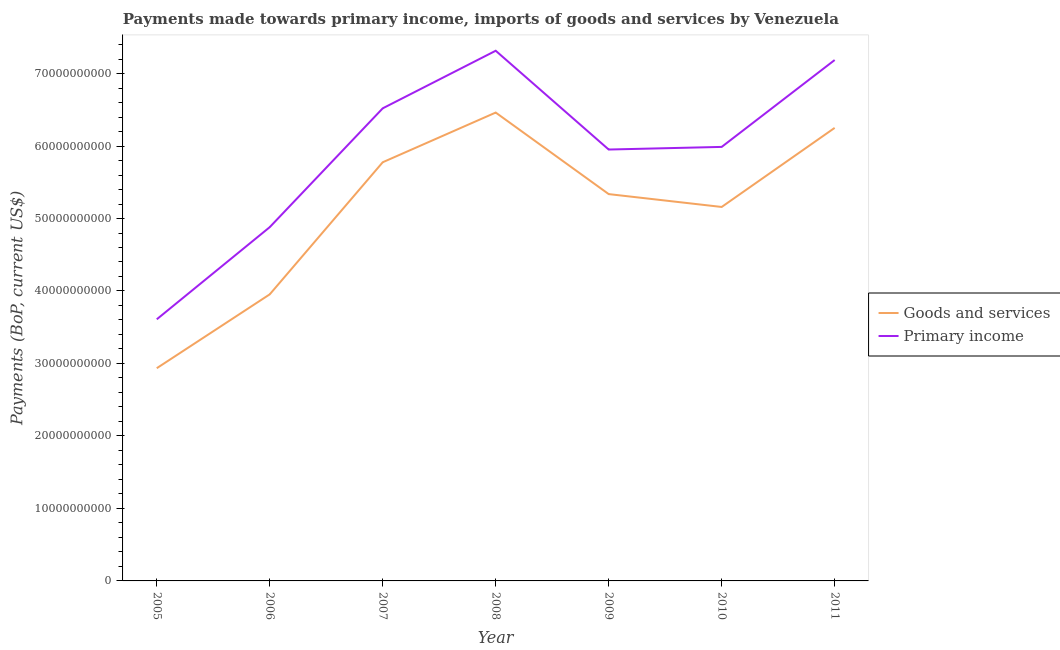How many different coloured lines are there?
Provide a short and direct response. 2. Does the line corresponding to payments made towards goods and services intersect with the line corresponding to payments made towards primary income?
Provide a short and direct response. No. What is the payments made towards primary income in 2008?
Provide a short and direct response. 7.31e+1. Across all years, what is the maximum payments made towards primary income?
Offer a terse response. 7.31e+1. Across all years, what is the minimum payments made towards goods and services?
Your answer should be compact. 2.93e+1. In which year was the payments made towards goods and services maximum?
Give a very brief answer. 2008. In which year was the payments made towards primary income minimum?
Provide a short and direct response. 2005. What is the total payments made towards primary income in the graph?
Provide a short and direct response. 4.15e+11. What is the difference between the payments made towards goods and services in 2008 and that in 2010?
Your answer should be very brief. 1.30e+1. What is the difference between the payments made towards primary income in 2009 and the payments made towards goods and services in 2008?
Offer a very short reply. -5.10e+09. What is the average payments made towards primary income per year?
Offer a very short reply. 5.92e+1. In the year 2008, what is the difference between the payments made towards primary income and payments made towards goods and services?
Provide a succinct answer. 8.53e+09. In how many years, is the payments made towards goods and services greater than 42000000000 US$?
Offer a terse response. 5. What is the ratio of the payments made towards primary income in 2005 to that in 2007?
Provide a succinct answer. 0.55. Is the payments made towards goods and services in 2006 less than that in 2010?
Offer a very short reply. Yes. What is the difference between the highest and the second highest payments made towards primary income?
Your answer should be very brief. 1.28e+09. What is the difference between the highest and the lowest payments made towards primary income?
Offer a terse response. 3.71e+1. Does the payments made towards goods and services monotonically increase over the years?
Offer a terse response. No. Is the payments made towards primary income strictly greater than the payments made towards goods and services over the years?
Keep it short and to the point. Yes. Is the payments made towards primary income strictly less than the payments made towards goods and services over the years?
Offer a terse response. No. How many lines are there?
Your answer should be compact. 2. Are the values on the major ticks of Y-axis written in scientific E-notation?
Your answer should be compact. No. Does the graph contain any zero values?
Your response must be concise. No. How many legend labels are there?
Provide a succinct answer. 2. What is the title of the graph?
Make the answer very short. Payments made towards primary income, imports of goods and services by Venezuela. What is the label or title of the X-axis?
Provide a succinct answer. Year. What is the label or title of the Y-axis?
Offer a very short reply. Payments (BoP, current US$). What is the Payments (BoP, current US$) in Goods and services in 2005?
Give a very brief answer. 2.93e+1. What is the Payments (BoP, current US$) of Primary income in 2005?
Provide a short and direct response. 3.61e+1. What is the Payments (BoP, current US$) in Goods and services in 2006?
Offer a very short reply. 3.95e+1. What is the Payments (BoP, current US$) of Primary income in 2006?
Keep it short and to the point. 4.88e+1. What is the Payments (BoP, current US$) in Goods and services in 2007?
Keep it short and to the point. 5.78e+1. What is the Payments (BoP, current US$) in Primary income in 2007?
Keep it short and to the point. 6.52e+1. What is the Payments (BoP, current US$) of Goods and services in 2008?
Your answer should be very brief. 6.46e+1. What is the Payments (BoP, current US$) in Primary income in 2008?
Make the answer very short. 7.31e+1. What is the Payments (BoP, current US$) of Goods and services in 2009?
Your answer should be very brief. 5.34e+1. What is the Payments (BoP, current US$) of Primary income in 2009?
Offer a terse response. 5.95e+1. What is the Payments (BoP, current US$) of Goods and services in 2010?
Provide a succinct answer. 5.16e+1. What is the Payments (BoP, current US$) of Primary income in 2010?
Your answer should be very brief. 5.99e+1. What is the Payments (BoP, current US$) in Goods and services in 2011?
Make the answer very short. 6.25e+1. What is the Payments (BoP, current US$) in Primary income in 2011?
Provide a short and direct response. 7.19e+1. Across all years, what is the maximum Payments (BoP, current US$) in Goods and services?
Your response must be concise. 6.46e+1. Across all years, what is the maximum Payments (BoP, current US$) of Primary income?
Your answer should be very brief. 7.31e+1. Across all years, what is the minimum Payments (BoP, current US$) in Goods and services?
Offer a very short reply. 2.93e+1. Across all years, what is the minimum Payments (BoP, current US$) of Primary income?
Keep it short and to the point. 3.61e+1. What is the total Payments (BoP, current US$) in Goods and services in the graph?
Provide a short and direct response. 3.59e+11. What is the total Payments (BoP, current US$) in Primary income in the graph?
Ensure brevity in your answer.  4.15e+11. What is the difference between the Payments (BoP, current US$) in Goods and services in 2005 and that in 2006?
Your response must be concise. -1.02e+1. What is the difference between the Payments (BoP, current US$) in Primary income in 2005 and that in 2006?
Give a very brief answer. -1.27e+1. What is the difference between the Payments (BoP, current US$) of Goods and services in 2005 and that in 2007?
Your answer should be compact. -2.84e+1. What is the difference between the Payments (BoP, current US$) in Primary income in 2005 and that in 2007?
Keep it short and to the point. -2.91e+1. What is the difference between the Payments (BoP, current US$) in Goods and services in 2005 and that in 2008?
Your answer should be compact. -3.53e+1. What is the difference between the Payments (BoP, current US$) of Primary income in 2005 and that in 2008?
Offer a very short reply. -3.71e+1. What is the difference between the Payments (BoP, current US$) in Goods and services in 2005 and that in 2009?
Your answer should be compact. -2.40e+1. What is the difference between the Payments (BoP, current US$) of Primary income in 2005 and that in 2009?
Give a very brief answer. -2.34e+1. What is the difference between the Payments (BoP, current US$) of Goods and services in 2005 and that in 2010?
Make the answer very short. -2.22e+1. What is the difference between the Payments (BoP, current US$) in Primary income in 2005 and that in 2010?
Provide a succinct answer. -2.38e+1. What is the difference between the Payments (BoP, current US$) of Goods and services in 2005 and that in 2011?
Ensure brevity in your answer.  -3.32e+1. What is the difference between the Payments (BoP, current US$) in Primary income in 2005 and that in 2011?
Provide a short and direct response. -3.58e+1. What is the difference between the Payments (BoP, current US$) in Goods and services in 2006 and that in 2007?
Provide a succinct answer. -1.82e+1. What is the difference between the Payments (BoP, current US$) of Primary income in 2006 and that in 2007?
Your answer should be very brief. -1.64e+1. What is the difference between the Payments (BoP, current US$) in Goods and services in 2006 and that in 2008?
Your answer should be compact. -2.51e+1. What is the difference between the Payments (BoP, current US$) of Primary income in 2006 and that in 2008?
Offer a terse response. -2.43e+1. What is the difference between the Payments (BoP, current US$) in Goods and services in 2006 and that in 2009?
Your answer should be compact. -1.38e+1. What is the difference between the Payments (BoP, current US$) in Primary income in 2006 and that in 2009?
Your response must be concise. -1.07e+1. What is the difference between the Payments (BoP, current US$) in Goods and services in 2006 and that in 2010?
Your answer should be compact. -1.21e+1. What is the difference between the Payments (BoP, current US$) of Primary income in 2006 and that in 2010?
Provide a short and direct response. -1.11e+1. What is the difference between the Payments (BoP, current US$) in Goods and services in 2006 and that in 2011?
Ensure brevity in your answer.  -2.30e+1. What is the difference between the Payments (BoP, current US$) in Primary income in 2006 and that in 2011?
Provide a short and direct response. -2.31e+1. What is the difference between the Payments (BoP, current US$) in Goods and services in 2007 and that in 2008?
Make the answer very short. -6.86e+09. What is the difference between the Payments (BoP, current US$) in Primary income in 2007 and that in 2008?
Offer a very short reply. -7.94e+09. What is the difference between the Payments (BoP, current US$) of Goods and services in 2007 and that in 2009?
Your response must be concise. 4.39e+09. What is the difference between the Payments (BoP, current US$) in Primary income in 2007 and that in 2009?
Ensure brevity in your answer.  5.68e+09. What is the difference between the Payments (BoP, current US$) of Goods and services in 2007 and that in 2010?
Give a very brief answer. 6.17e+09. What is the difference between the Payments (BoP, current US$) in Primary income in 2007 and that in 2010?
Your answer should be very brief. 5.32e+09. What is the difference between the Payments (BoP, current US$) of Goods and services in 2007 and that in 2011?
Provide a short and direct response. -4.74e+09. What is the difference between the Payments (BoP, current US$) of Primary income in 2007 and that in 2011?
Offer a very short reply. -6.66e+09. What is the difference between the Payments (BoP, current US$) of Goods and services in 2008 and that in 2009?
Your response must be concise. 1.12e+1. What is the difference between the Payments (BoP, current US$) in Primary income in 2008 and that in 2009?
Your answer should be compact. 1.36e+1. What is the difference between the Payments (BoP, current US$) of Goods and services in 2008 and that in 2010?
Your answer should be compact. 1.30e+1. What is the difference between the Payments (BoP, current US$) in Primary income in 2008 and that in 2010?
Ensure brevity in your answer.  1.33e+1. What is the difference between the Payments (BoP, current US$) in Goods and services in 2008 and that in 2011?
Your answer should be very brief. 2.12e+09. What is the difference between the Payments (BoP, current US$) in Primary income in 2008 and that in 2011?
Offer a very short reply. 1.28e+09. What is the difference between the Payments (BoP, current US$) in Goods and services in 2009 and that in 2010?
Your response must be concise. 1.77e+09. What is the difference between the Payments (BoP, current US$) of Primary income in 2009 and that in 2010?
Your answer should be compact. -3.62e+08. What is the difference between the Payments (BoP, current US$) of Goods and services in 2009 and that in 2011?
Provide a succinct answer. -9.14e+09. What is the difference between the Payments (BoP, current US$) in Primary income in 2009 and that in 2011?
Offer a very short reply. -1.23e+1. What is the difference between the Payments (BoP, current US$) in Goods and services in 2010 and that in 2011?
Provide a short and direct response. -1.09e+1. What is the difference between the Payments (BoP, current US$) in Primary income in 2010 and that in 2011?
Keep it short and to the point. -1.20e+1. What is the difference between the Payments (BoP, current US$) in Goods and services in 2005 and the Payments (BoP, current US$) in Primary income in 2006?
Provide a short and direct response. -1.95e+1. What is the difference between the Payments (BoP, current US$) of Goods and services in 2005 and the Payments (BoP, current US$) of Primary income in 2007?
Ensure brevity in your answer.  -3.59e+1. What is the difference between the Payments (BoP, current US$) of Goods and services in 2005 and the Payments (BoP, current US$) of Primary income in 2008?
Ensure brevity in your answer.  -4.38e+1. What is the difference between the Payments (BoP, current US$) of Goods and services in 2005 and the Payments (BoP, current US$) of Primary income in 2009?
Keep it short and to the point. -3.02e+1. What is the difference between the Payments (BoP, current US$) in Goods and services in 2005 and the Payments (BoP, current US$) in Primary income in 2010?
Provide a succinct answer. -3.05e+1. What is the difference between the Payments (BoP, current US$) in Goods and services in 2005 and the Payments (BoP, current US$) in Primary income in 2011?
Provide a short and direct response. -4.25e+1. What is the difference between the Payments (BoP, current US$) of Goods and services in 2006 and the Payments (BoP, current US$) of Primary income in 2007?
Offer a terse response. -2.57e+1. What is the difference between the Payments (BoP, current US$) of Goods and services in 2006 and the Payments (BoP, current US$) of Primary income in 2008?
Make the answer very short. -3.36e+1. What is the difference between the Payments (BoP, current US$) in Goods and services in 2006 and the Payments (BoP, current US$) in Primary income in 2009?
Offer a very short reply. -2.00e+1. What is the difference between the Payments (BoP, current US$) of Goods and services in 2006 and the Payments (BoP, current US$) of Primary income in 2010?
Ensure brevity in your answer.  -2.03e+1. What is the difference between the Payments (BoP, current US$) of Goods and services in 2006 and the Payments (BoP, current US$) of Primary income in 2011?
Offer a terse response. -3.23e+1. What is the difference between the Payments (BoP, current US$) in Goods and services in 2007 and the Payments (BoP, current US$) in Primary income in 2008?
Provide a succinct answer. -1.54e+1. What is the difference between the Payments (BoP, current US$) in Goods and services in 2007 and the Payments (BoP, current US$) in Primary income in 2009?
Your answer should be very brief. -1.76e+09. What is the difference between the Payments (BoP, current US$) in Goods and services in 2007 and the Payments (BoP, current US$) in Primary income in 2010?
Provide a short and direct response. -2.12e+09. What is the difference between the Payments (BoP, current US$) in Goods and services in 2007 and the Payments (BoP, current US$) in Primary income in 2011?
Offer a terse response. -1.41e+1. What is the difference between the Payments (BoP, current US$) of Goods and services in 2008 and the Payments (BoP, current US$) of Primary income in 2009?
Give a very brief answer. 5.10e+09. What is the difference between the Payments (BoP, current US$) of Goods and services in 2008 and the Payments (BoP, current US$) of Primary income in 2010?
Provide a short and direct response. 4.74e+09. What is the difference between the Payments (BoP, current US$) of Goods and services in 2008 and the Payments (BoP, current US$) of Primary income in 2011?
Provide a succinct answer. -7.25e+09. What is the difference between the Payments (BoP, current US$) in Goods and services in 2009 and the Payments (BoP, current US$) in Primary income in 2010?
Offer a very short reply. -6.51e+09. What is the difference between the Payments (BoP, current US$) in Goods and services in 2009 and the Payments (BoP, current US$) in Primary income in 2011?
Your response must be concise. -1.85e+1. What is the difference between the Payments (BoP, current US$) in Goods and services in 2010 and the Payments (BoP, current US$) in Primary income in 2011?
Provide a succinct answer. -2.03e+1. What is the average Payments (BoP, current US$) in Goods and services per year?
Your response must be concise. 5.12e+1. What is the average Payments (BoP, current US$) in Primary income per year?
Make the answer very short. 5.92e+1. In the year 2005, what is the difference between the Payments (BoP, current US$) in Goods and services and Payments (BoP, current US$) in Primary income?
Your response must be concise. -6.75e+09. In the year 2006, what is the difference between the Payments (BoP, current US$) in Goods and services and Payments (BoP, current US$) in Primary income?
Your answer should be compact. -9.27e+09. In the year 2007, what is the difference between the Payments (BoP, current US$) in Goods and services and Payments (BoP, current US$) in Primary income?
Offer a terse response. -7.44e+09. In the year 2008, what is the difference between the Payments (BoP, current US$) of Goods and services and Payments (BoP, current US$) of Primary income?
Offer a terse response. -8.53e+09. In the year 2009, what is the difference between the Payments (BoP, current US$) in Goods and services and Payments (BoP, current US$) in Primary income?
Your response must be concise. -6.15e+09. In the year 2010, what is the difference between the Payments (BoP, current US$) in Goods and services and Payments (BoP, current US$) in Primary income?
Your response must be concise. -8.28e+09. In the year 2011, what is the difference between the Payments (BoP, current US$) of Goods and services and Payments (BoP, current US$) of Primary income?
Your response must be concise. -9.36e+09. What is the ratio of the Payments (BoP, current US$) of Goods and services in 2005 to that in 2006?
Keep it short and to the point. 0.74. What is the ratio of the Payments (BoP, current US$) of Primary income in 2005 to that in 2006?
Your answer should be compact. 0.74. What is the ratio of the Payments (BoP, current US$) of Goods and services in 2005 to that in 2007?
Make the answer very short. 0.51. What is the ratio of the Payments (BoP, current US$) in Primary income in 2005 to that in 2007?
Your response must be concise. 0.55. What is the ratio of the Payments (BoP, current US$) of Goods and services in 2005 to that in 2008?
Give a very brief answer. 0.45. What is the ratio of the Payments (BoP, current US$) in Primary income in 2005 to that in 2008?
Your response must be concise. 0.49. What is the ratio of the Payments (BoP, current US$) of Goods and services in 2005 to that in 2009?
Ensure brevity in your answer.  0.55. What is the ratio of the Payments (BoP, current US$) in Primary income in 2005 to that in 2009?
Provide a succinct answer. 0.61. What is the ratio of the Payments (BoP, current US$) in Goods and services in 2005 to that in 2010?
Provide a short and direct response. 0.57. What is the ratio of the Payments (BoP, current US$) of Primary income in 2005 to that in 2010?
Offer a terse response. 0.6. What is the ratio of the Payments (BoP, current US$) of Goods and services in 2005 to that in 2011?
Offer a terse response. 0.47. What is the ratio of the Payments (BoP, current US$) in Primary income in 2005 to that in 2011?
Your answer should be very brief. 0.5. What is the ratio of the Payments (BoP, current US$) of Goods and services in 2006 to that in 2007?
Ensure brevity in your answer.  0.68. What is the ratio of the Payments (BoP, current US$) of Primary income in 2006 to that in 2007?
Your response must be concise. 0.75. What is the ratio of the Payments (BoP, current US$) in Goods and services in 2006 to that in 2008?
Give a very brief answer. 0.61. What is the ratio of the Payments (BoP, current US$) of Primary income in 2006 to that in 2008?
Keep it short and to the point. 0.67. What is the ratio of the Payments (BoP, current US$) in Goods and services in 2006 to that in 2009?
Offer a terse response. 0.74. What is the ratio of the Payments (BoP, current US$) in Primary income in 2006 to that in 2009?
Offer a terse response. 0.82. What is the ratio of the Payments (BoP, current US$) in Goods and services in 2006 to that in 2010?
Provide a succinct answer. 0.77. What is the ratio of the Payments (BoP, current US$) of Primary income in 2006 to that in 2010?
Provide a succinct answer. 0.82. What is the ratio of the Payments (BoP, current US$) in Goods and services in 2006 to that in 2011?
Your response must be concise. 0.63. What is the ratio of the Payments (BoP, current US$) of Primary income in 2006 to that in 2011?
Provide a short and direct response. 0.68. What is the ratio of the Payments (BoP, current US$) in Goods and services in 2007 to that in 2008?
Make the answer very short. 0.89. What is the ratio of the Payments (BoP, current US$) in Primary income in 2007 to that in 2008?
Provide a short and direct response. 0.89. What is the ratio of the Payments (BoP, current US$) in Goods and services in 2007 to that in 2009?
Provide a short and direct response. 1.08. What is the ratio of the Payments (BoP, current US$) of Primary income in 2007 to that in 2009?
Your response must be concise. 1.1. What is the ratio of the Payments (BoP, current US$) of Goods and services in 2007 to that in 2010?
Offer a terse response. 1.12. What is the ratio of the Payments (BoP, current US$) of Primary income in 2007 to that in 2010?
Keep it short and to the point. 1.09. What is the ratio of the Payments (BoP, current US$) of Goods and services in 2007 to that in 2011?
Ensure brevity in your answer.  0.92. What is the ratio of the Payments (BoP, current US$) of Primary income in 2007 to that in 2011?
Give a very brief answer. 0.91. What is the ratio of the Payments (BoP, current US$) of Goods and services in 2008 to that in 2009?
Your answer should be very brief. 1.21. What is the ratio of the Payments (BoP, current US$) in Primary income in 2008 to that in 2009?
Provide a short and direct response. 1.23. What is the ratio of the Payments (BoP, current US$) of Goods and services in 2008 to that in 2010?
Offer a terse response. 1.25. What is the ratio of the Payments (BoP, current US$) of Primary income in 2008 to that in 2010?
Offer a very short reply. 1.22. What is the ratio of the Payments (BoP, current US$) in Goods and services in 2008 to that in 2011?
Your response must be concise. 1.03. What is the ratio of the Payments (BoP, current US$) of Primary income in 2008 to that in 2011?
Offer a very short reply. 1.02. What is the ratio of the Payments (BoP, current US$) of Goods and services in 2009 to that in 2010?
Offer a terse response. 1.03. What is the ratio of the Payments (BoP, current US$) in Primary income in 2009 to that in 2010?
Your answer should be very brief. 0.99. What is the ratio of the Payments (BoP, current US$) in Goods and services in 2009 to that in 2011?
Your answer should be very brief. 0.85. What is the ratio of the Payments (BoP, current US$) of Primary income in 2009 to that in 2011?
Give a very brief answer. 0.83. What is the ratio of the Payments (BoP, current US$) of Goods and services in 2010 to that in 2011?
Make the answer very short. 0.83. What is the ratio of the Payments (BoP, current US$) of Primary income in 2010 to that in 2011?
Give a very brief answer. 0.83. What is the difference between the highest and the second highest Payments (BoP, current US$) of Goods and services?
Your response must be concise. 2.12e+09. What is the difference between the highest and the second highest Payments (BoP, current US$) in Primary income?
Give a very brief answer. 1.28e+09. What is the difference between the highest and the lowest Payments (BoP, current US$) of Goods and services?
Offer a terse response. 3.53e+1. What is the difference between the highest and the lowest Payments (BoP, current US$) in Primary income?
Give a very brief answer. 3.71e+1. 